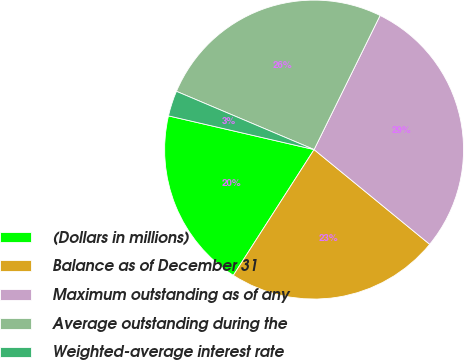Convert chart to OTSL. <chart><loc_0><loc_0><loc_500><loc_500><pie_chart><fcel>(Dollars in millions)<fcel>Balance as of December 31<fcel>Maximum outstanding as of any<fcel>Average outstanding during the<fcel>Weighted-average interest rate<nl><fcel>19.54%<fcel>23.16%<fcel>28.65%<fcel>25.91%<fcel>2.75%<nl></chart> 